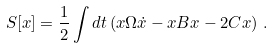<formula> <loc_0><loc_0><loc_500><loc_500>S [ x ] = \frac { 1 } { 2 } \int d t \left ( x \Omega \dot { x } - x B x - 2 C x \right ) \, .</formula> 